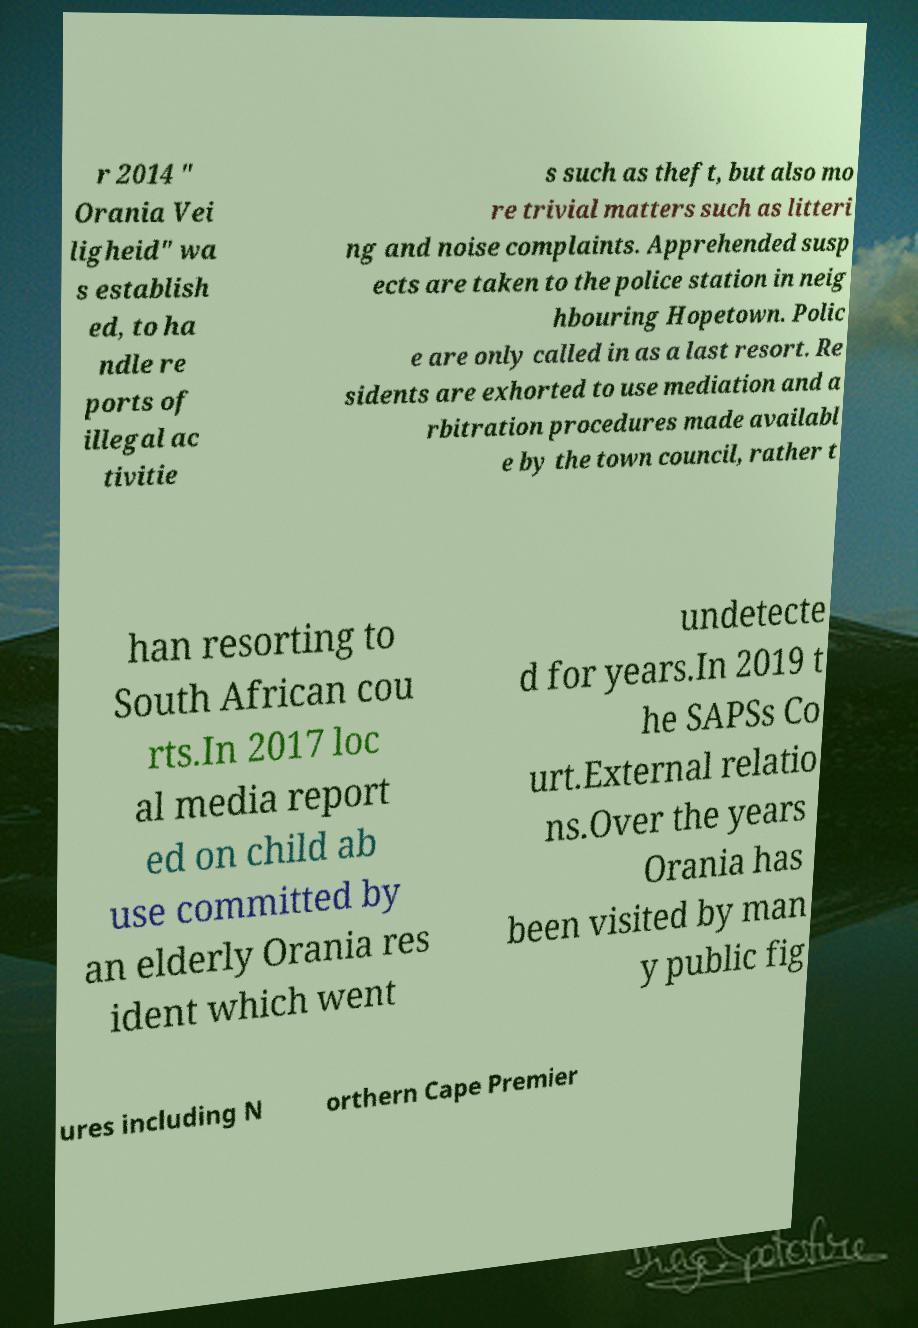I need the written content from this picture converted into text. Can you do that? r 2014 " Orania Vei ligheid" wa s establish ed, to ha ndle re ports of illegal ac tivitie s such as theft, but also mo re trivial matters such as litteri ng and noise complaints. Apprehended susp ects are taken to the police station in neig hbouring Hopetown. Polic e are only called in as a last resort. Re sidents are exhorted to use mediation and a rbitration procedures made availabl e by the town council, rather t han resorting to South African cou rts.In 2017 loc al media report ed on child ab use committed by an elderly Orania res ident which went undetecte d for years.In 2019 t he SAPSs Co urt.External relatio ns.Over the years Orania has been visited by man y public fig ures including N orthern Cape Premier 